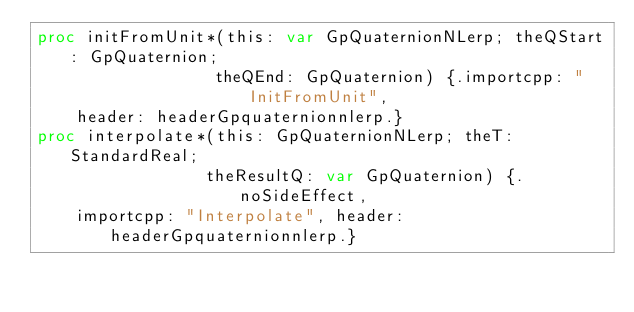<code> <loc_0><loc_0><loc_500><loc_500><_Nim_>proc initFromUnit*(this: var GpQuaternionNLerp; theQStart: GpQuaternion;
                  theQEnd: GpQuaternion) {.importcpp: "InitFromUnit",
    header: headerGpquaternionnlerp.}
proc interpolate*(this: GpQuaternionNLerp; theT: StandardReal;
                 theResultQ: var GpQuaternion) {.noSideEffect,
    importcpp: "Interpolate", header: headerGpquaternionnlerp.}</code> 